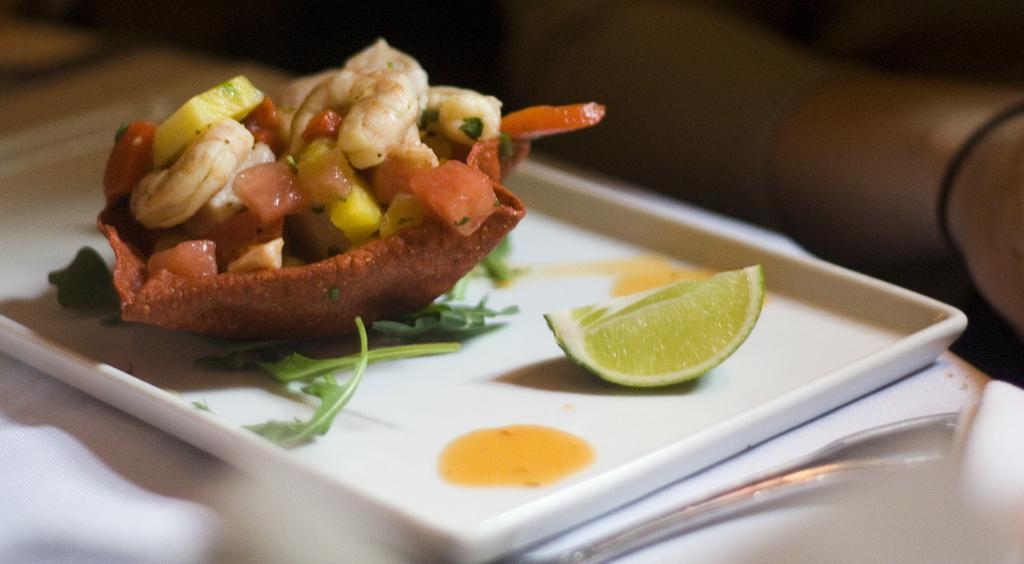How would you summarize this image in a sentence or two? This image consists of food which is on the plate. 